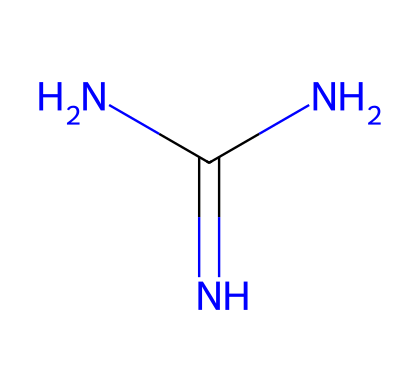How many nitrogen atoms are present in guanidine? The SMILES representation shows three nitrogen atoms, indicated by the 'N' symbols in the structure.
Answer: three What is the functional group of guanidine? Guanidine contains an amine functional group, as there are nitrogen atoms bonded to carbon and hydrogen.
Answer: amine What is the degree of acidity of guanidine? Guanidine is a strong base due to the presence of multiple nitrogen atoms which can accept protons easily.
Answer: strong base What is the hybridization of the central carbon atom in guanidine? The central carbon atom is bonded to three other atoms (two nitrogens and one nitrogen with a double bond), which indicates it is sp^2 hybridized.
Answer: sp2 What is the molecular formula of guanidine? To determine the molecular formula, we count 1 carbon, 4 hydrogens, and 3 nitrogens from the SMILES representation, giving C1H4N3.
Answer: C1H4N3 How does guanidine’s structure relate to its basic properties? The presence of multiple nitrogen atoms allows for electron donation, making guanidine a strong base as it can readily accept protons.
Answer: electron donation 